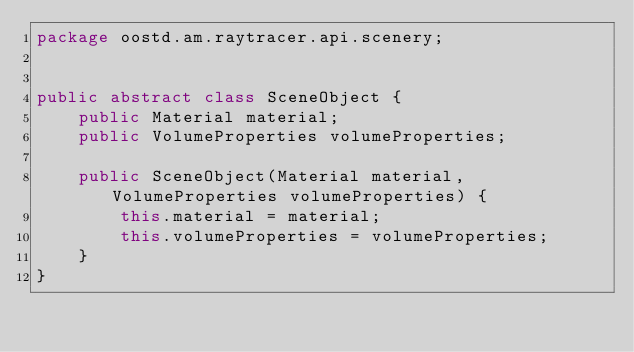Convert code to text. <code><loc_0><loc_0><loc_500><loc_500><_Java_>package oostd.am.raytracer.api.scenery;


public abstract class SceneObject {
    public Material material;
    public VolumeProperties volumeProperties;

    public SceneObject(Material material, VolumeProperties volumeProperties) {
        this.material = material;
        this.volumeProperties = volumeProperties;
    }
}
</code> 